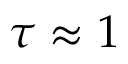Convert formula to latex. <formula><loc_0><loc_0><loc_500><loc_500>\tau \approx 1</formula> 